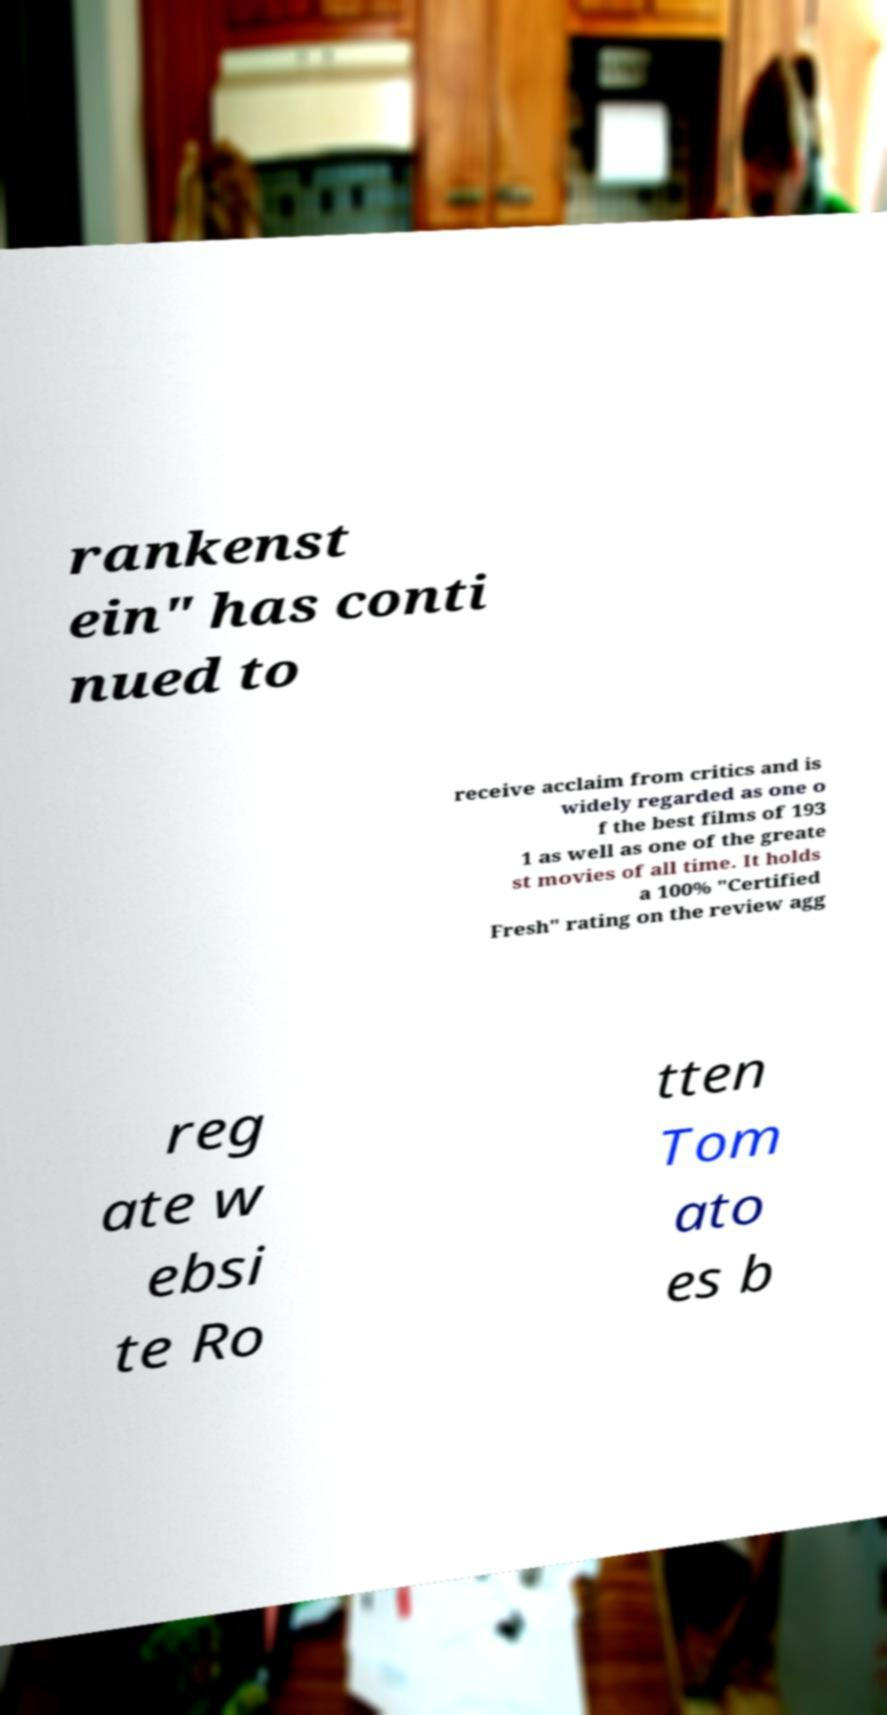Can you accurately transcribe the text from the provided image for me? rankenst ein" has conti nued to receive acclaim from critics and is widely regarded as one o f the best films of 193 1 as well as one of the greate st movies of all time. It holds a 100% "Certified Fresh" rating on the review agg reg ate w ebsi te Ro tten Tom ato es b 